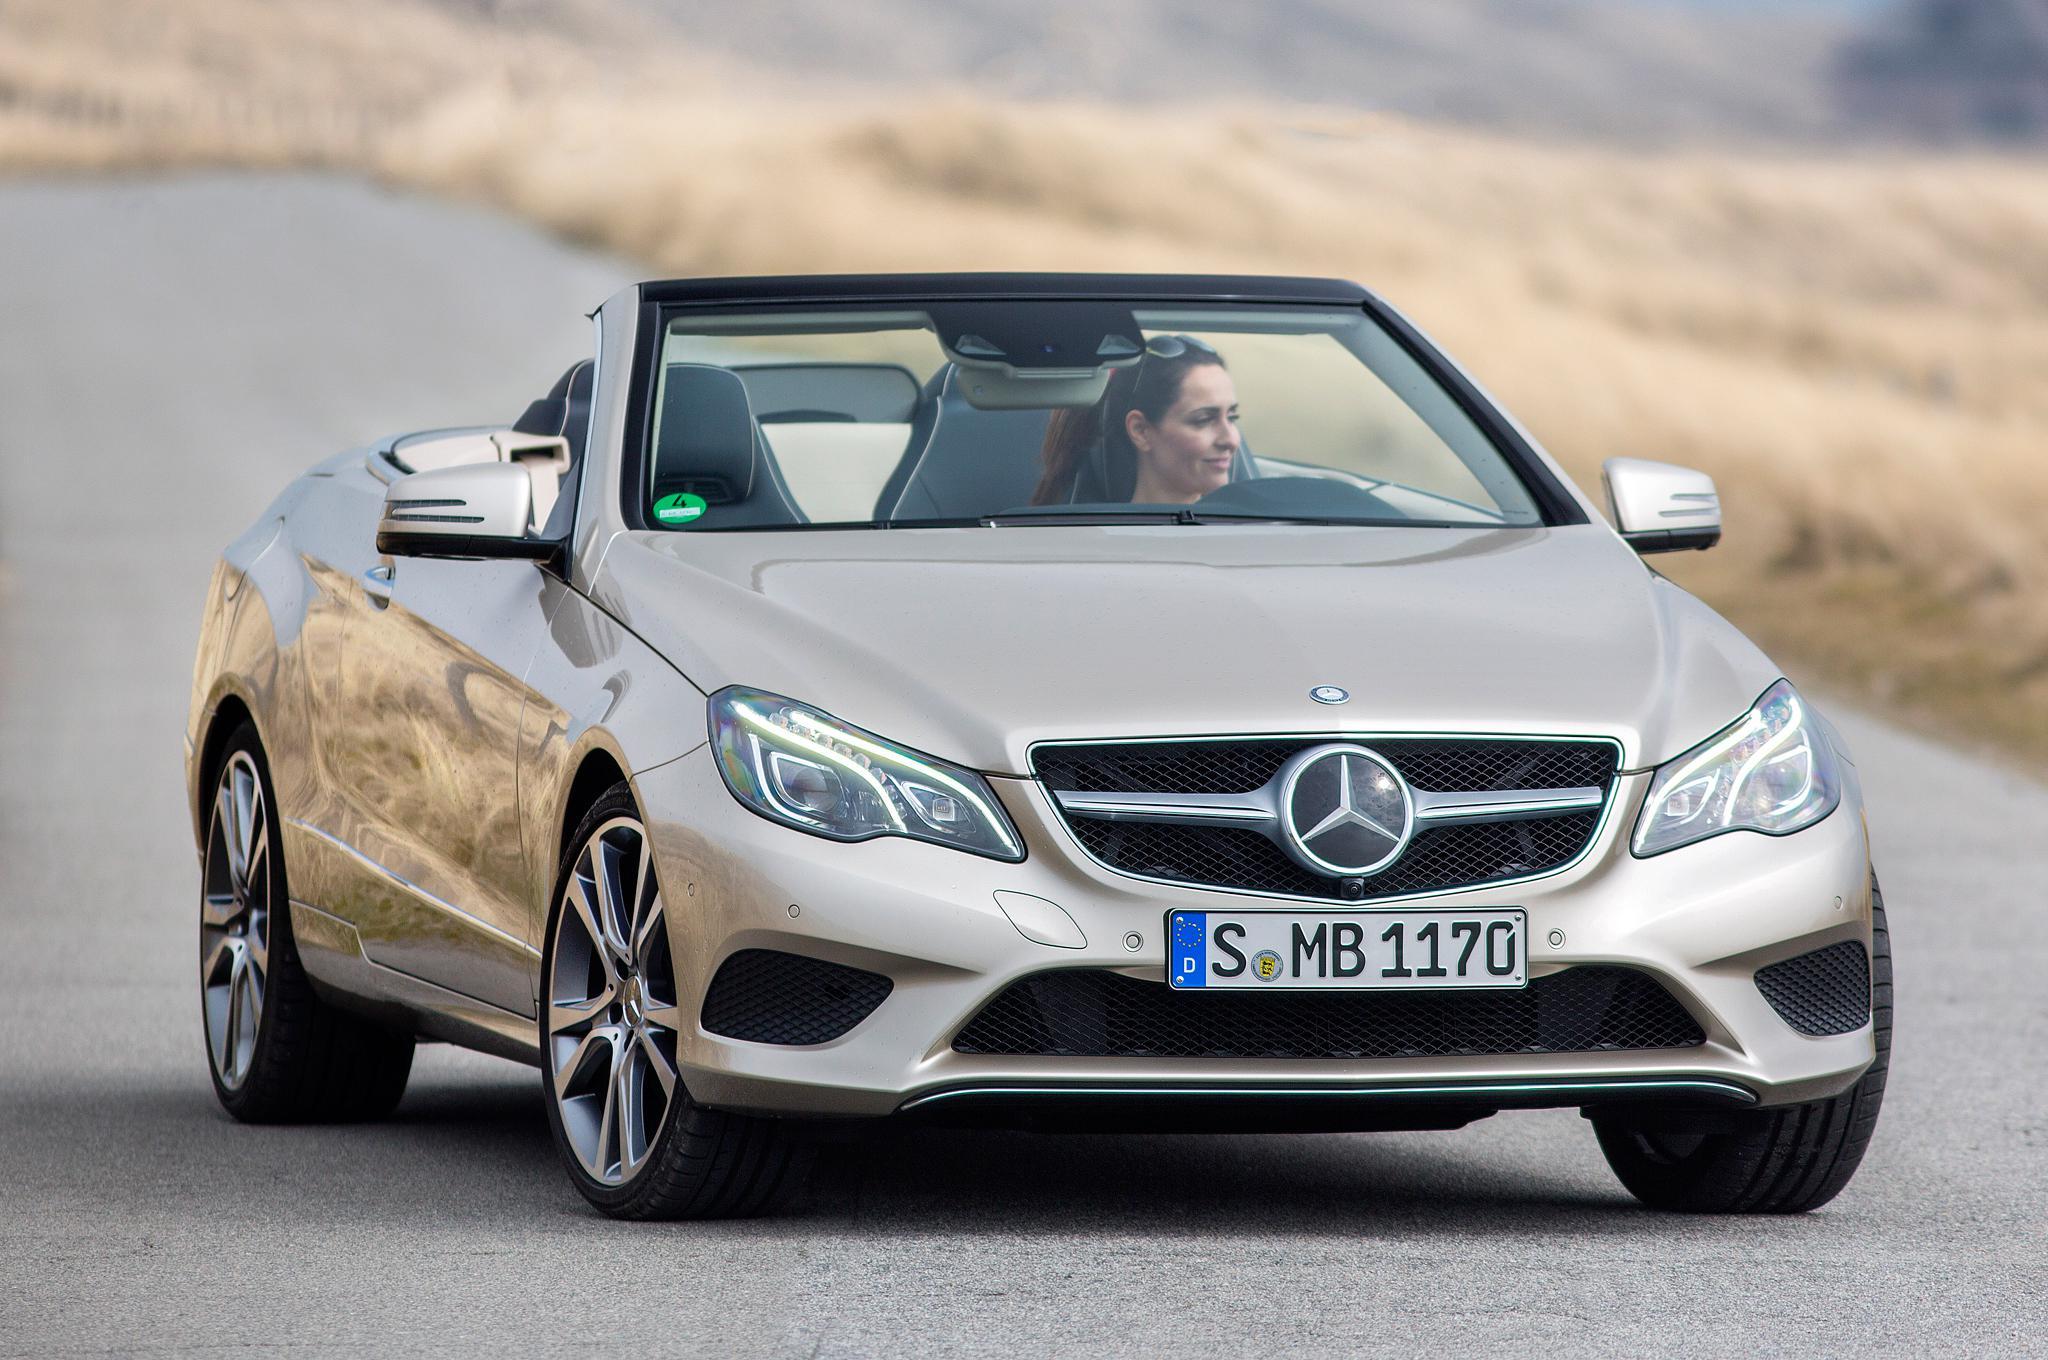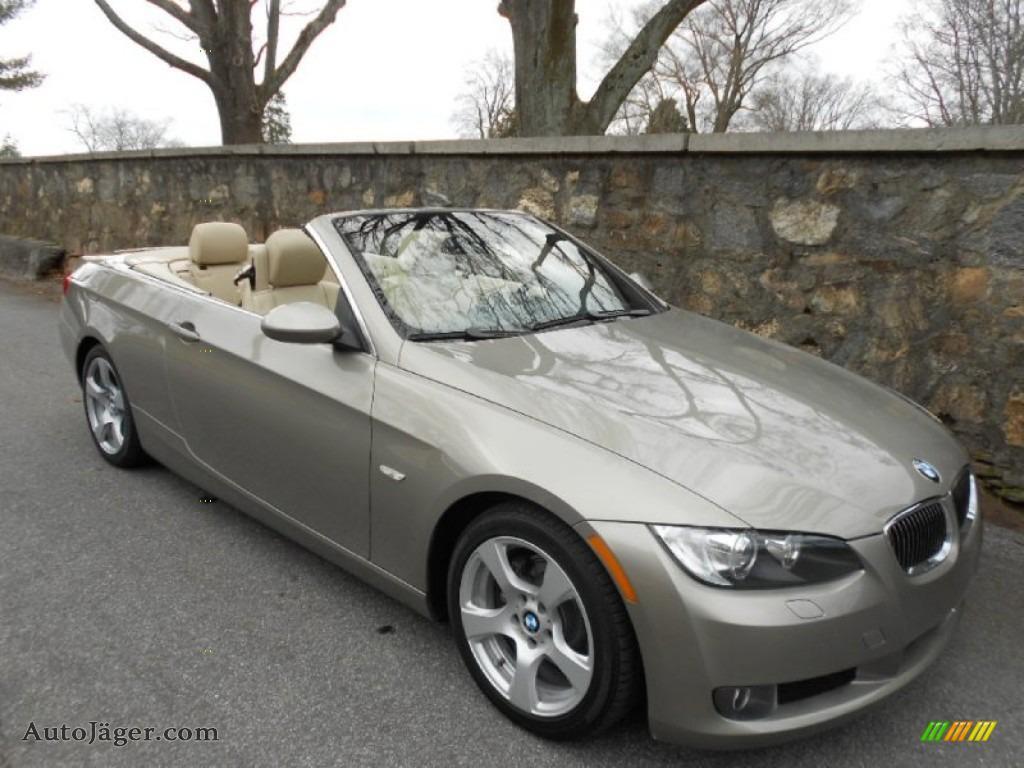The first image is the image on the left, the second image is the image on the right. Evaluate the accuracy of this statement regarding the images: "Two convertibles with black interior are facing foreward in different directions, both with chrome wheels, but only one with a license plate.". Is it true? Answer yes or no. No. 